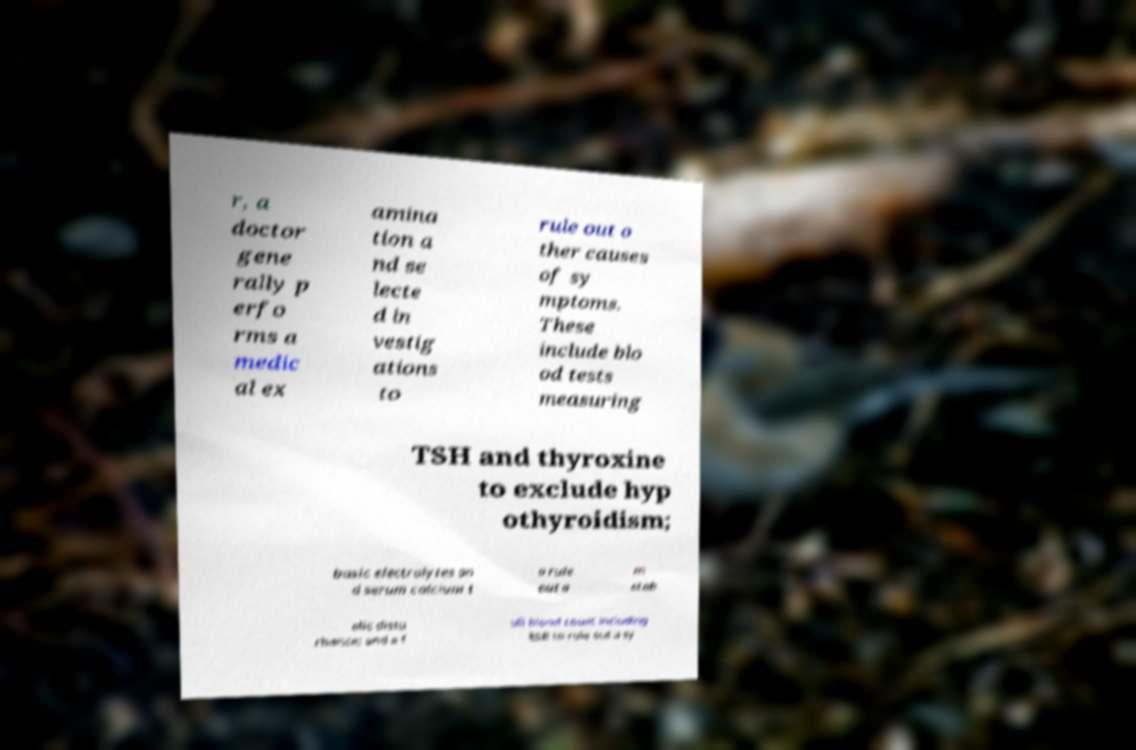I need the written content from this picture converted into text. Can you do that? r, a doctor gene rally p erfo rms a medic al ex amina tion a nd se lecte d in vestig ations to rule out o ther causes of sy mptoms. These include blo od tests measuring TSH and thyroxine to exclude hyp othyroidism; basic electrolytes an d serum calcium t o rule out a m etab olic distu rbance; and a f ull blood count including ESR to rule out a sy 